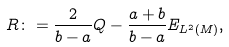Convert formula to latex. <formula><loc_0><loc_0><loc_500><loc_500>R \colon = \frac { 2 } { b - a } Q - \frac { a + b } { b - a } E _ { L ^ { 2 } ( M ) } ,</formula> 